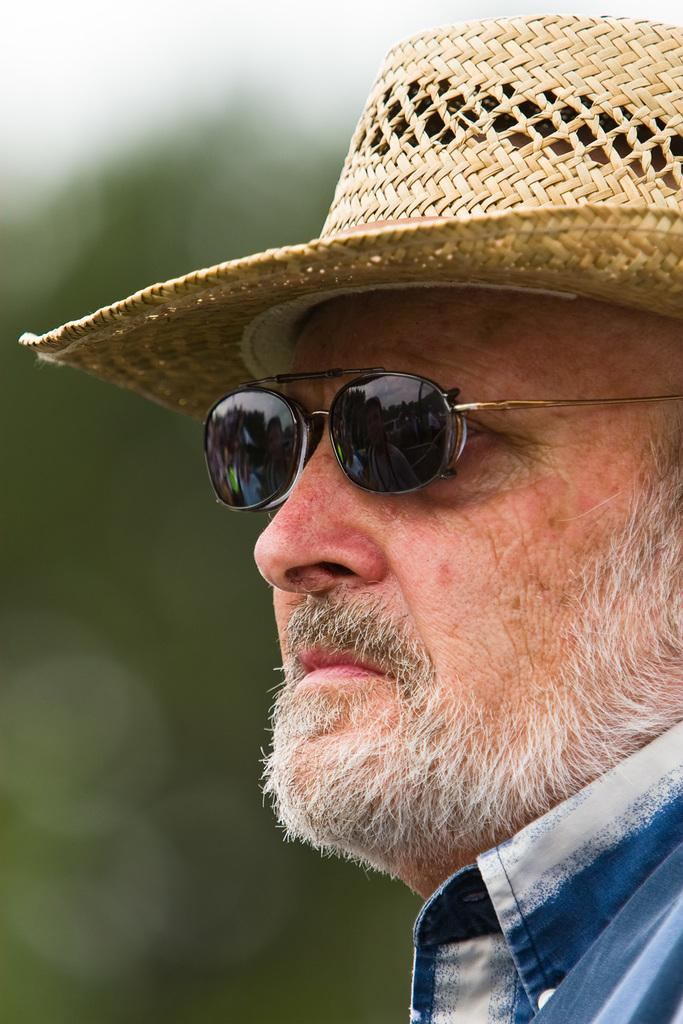What is the main subject of the image? There is a person in the image. What accessories is the person wearing? The person is wearing a hat and goggles. Can you describe the background of the image? The background of the image is blurry. What is the person's level of wealth in the image? There is no information about the person's wealth in the image. What can be seen in the aftermath of the event in the image? There is no event or aftermath depicted in the image; it features a person wearing a hat and goggles against a blurry background. 